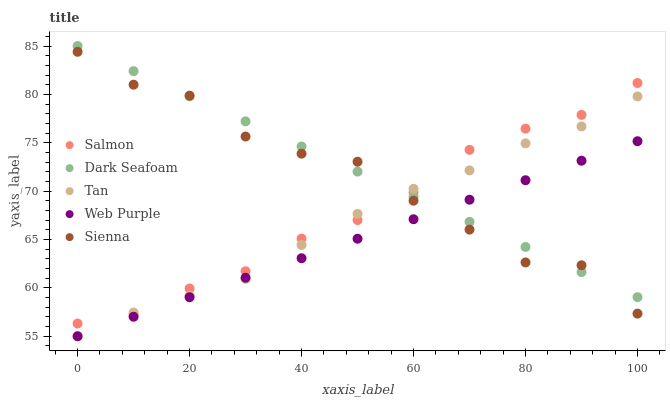Does Web Purple have the minimum area under the curve?
Answer yes or no. Yes. Does Dark Seafoam have the maximum area under the curve?
Answer yes or no. Yes. Does Dark Seafoam have the minimum area under the curve?
Answer yes or no. No. Does Web Purple have the maximum area under the curve?
Answer yes or no. No. Is Web Purple the smoothest?
Answer yes or no. Yes. Is Sienna the roughest?
Answer yes or no. Yes. Is Dark Seafoam the smoothest?
Answer yes or no. No. Is Dark Seafoam the roughest?
Answer yes or no. No. Does Web Purple have the lowest value?
Answer yes or no. Yes. Does Dark Seafoam have the lowest value?
Answer yes or no. No. Does Dark Seafoam have the highest value?
Answer yes or no. Yes. Does Web Purple have the highest value?
Answer yes or no. No. Is Web Purple less than Salmon?
Answer yes or no. Yes. Is Salmon greater than Web Purple?
Answer yes or no. Yes. Does Web Purple intersect Dark Seafoam?
Answer yes or no. Yes. Is Web Purple less than Dark Seafoam?
Answer yes or no. No. Is Web Purple greater than Dark Seafoam?
Answer yes or no. No. Does Web Purple intersect Salmon?
Answer yes or no. No. 